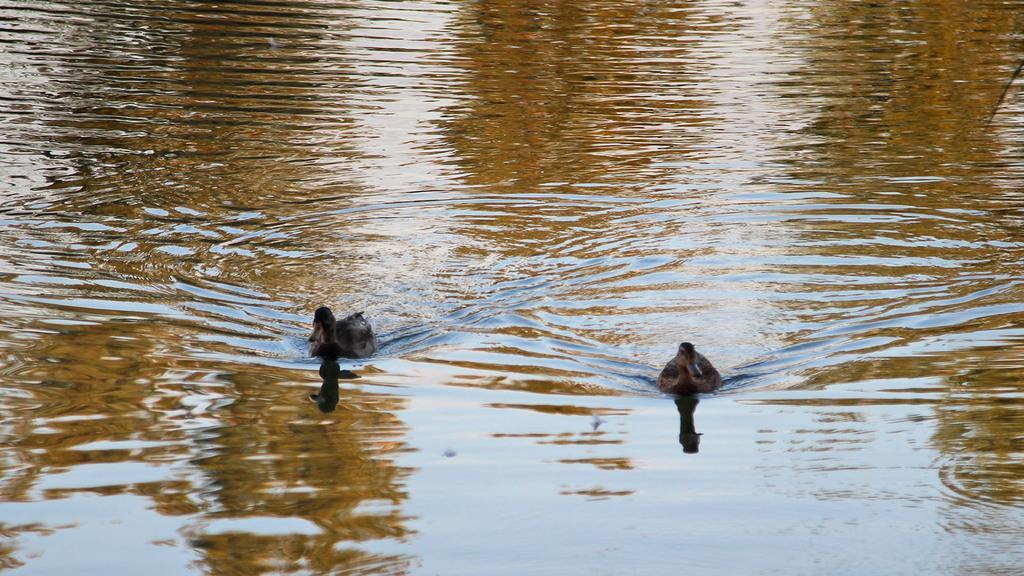Could you give a brief overview of what you see in this image? In this image there are two ducks in the water. 